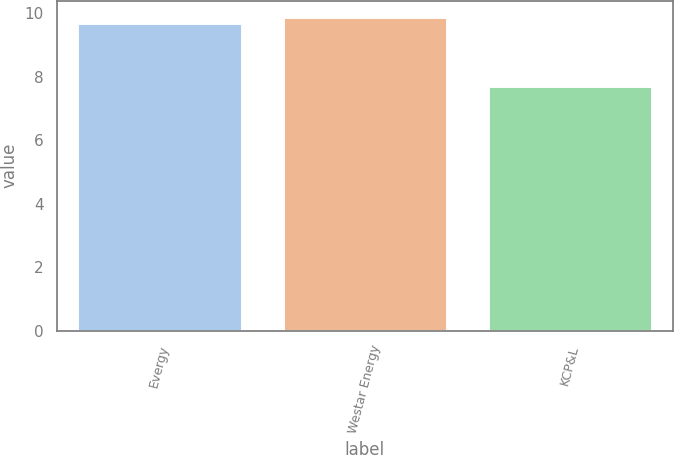<chart> <loc_0><loc_0><loc_500><loc_500><bar_chart><fcel>Evergy<fcel>Westar Energy<fcel>KCP&L<nl><fcel>9.7<fcel>9.9<fcel>7.7<nl></chart> 